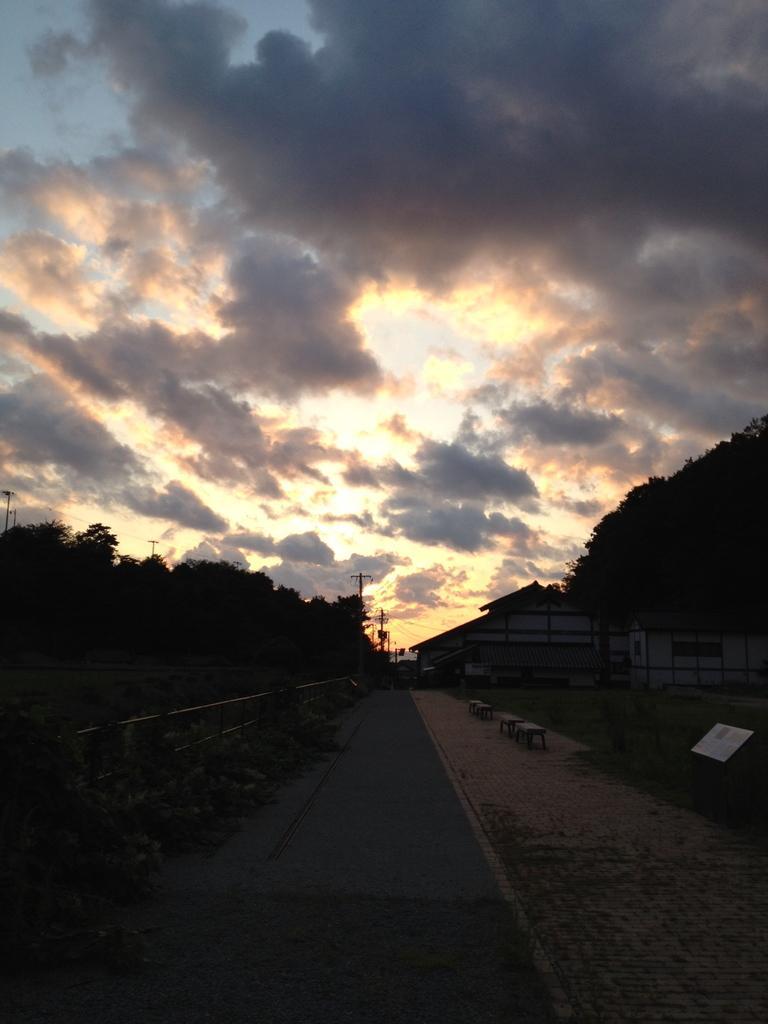Could you give a brief overview of what you see in this image? In this image I can see the road. To the side of the road I can see the boards and the railing. In the background there is a house, many trees, poles, clouds and the sky. 